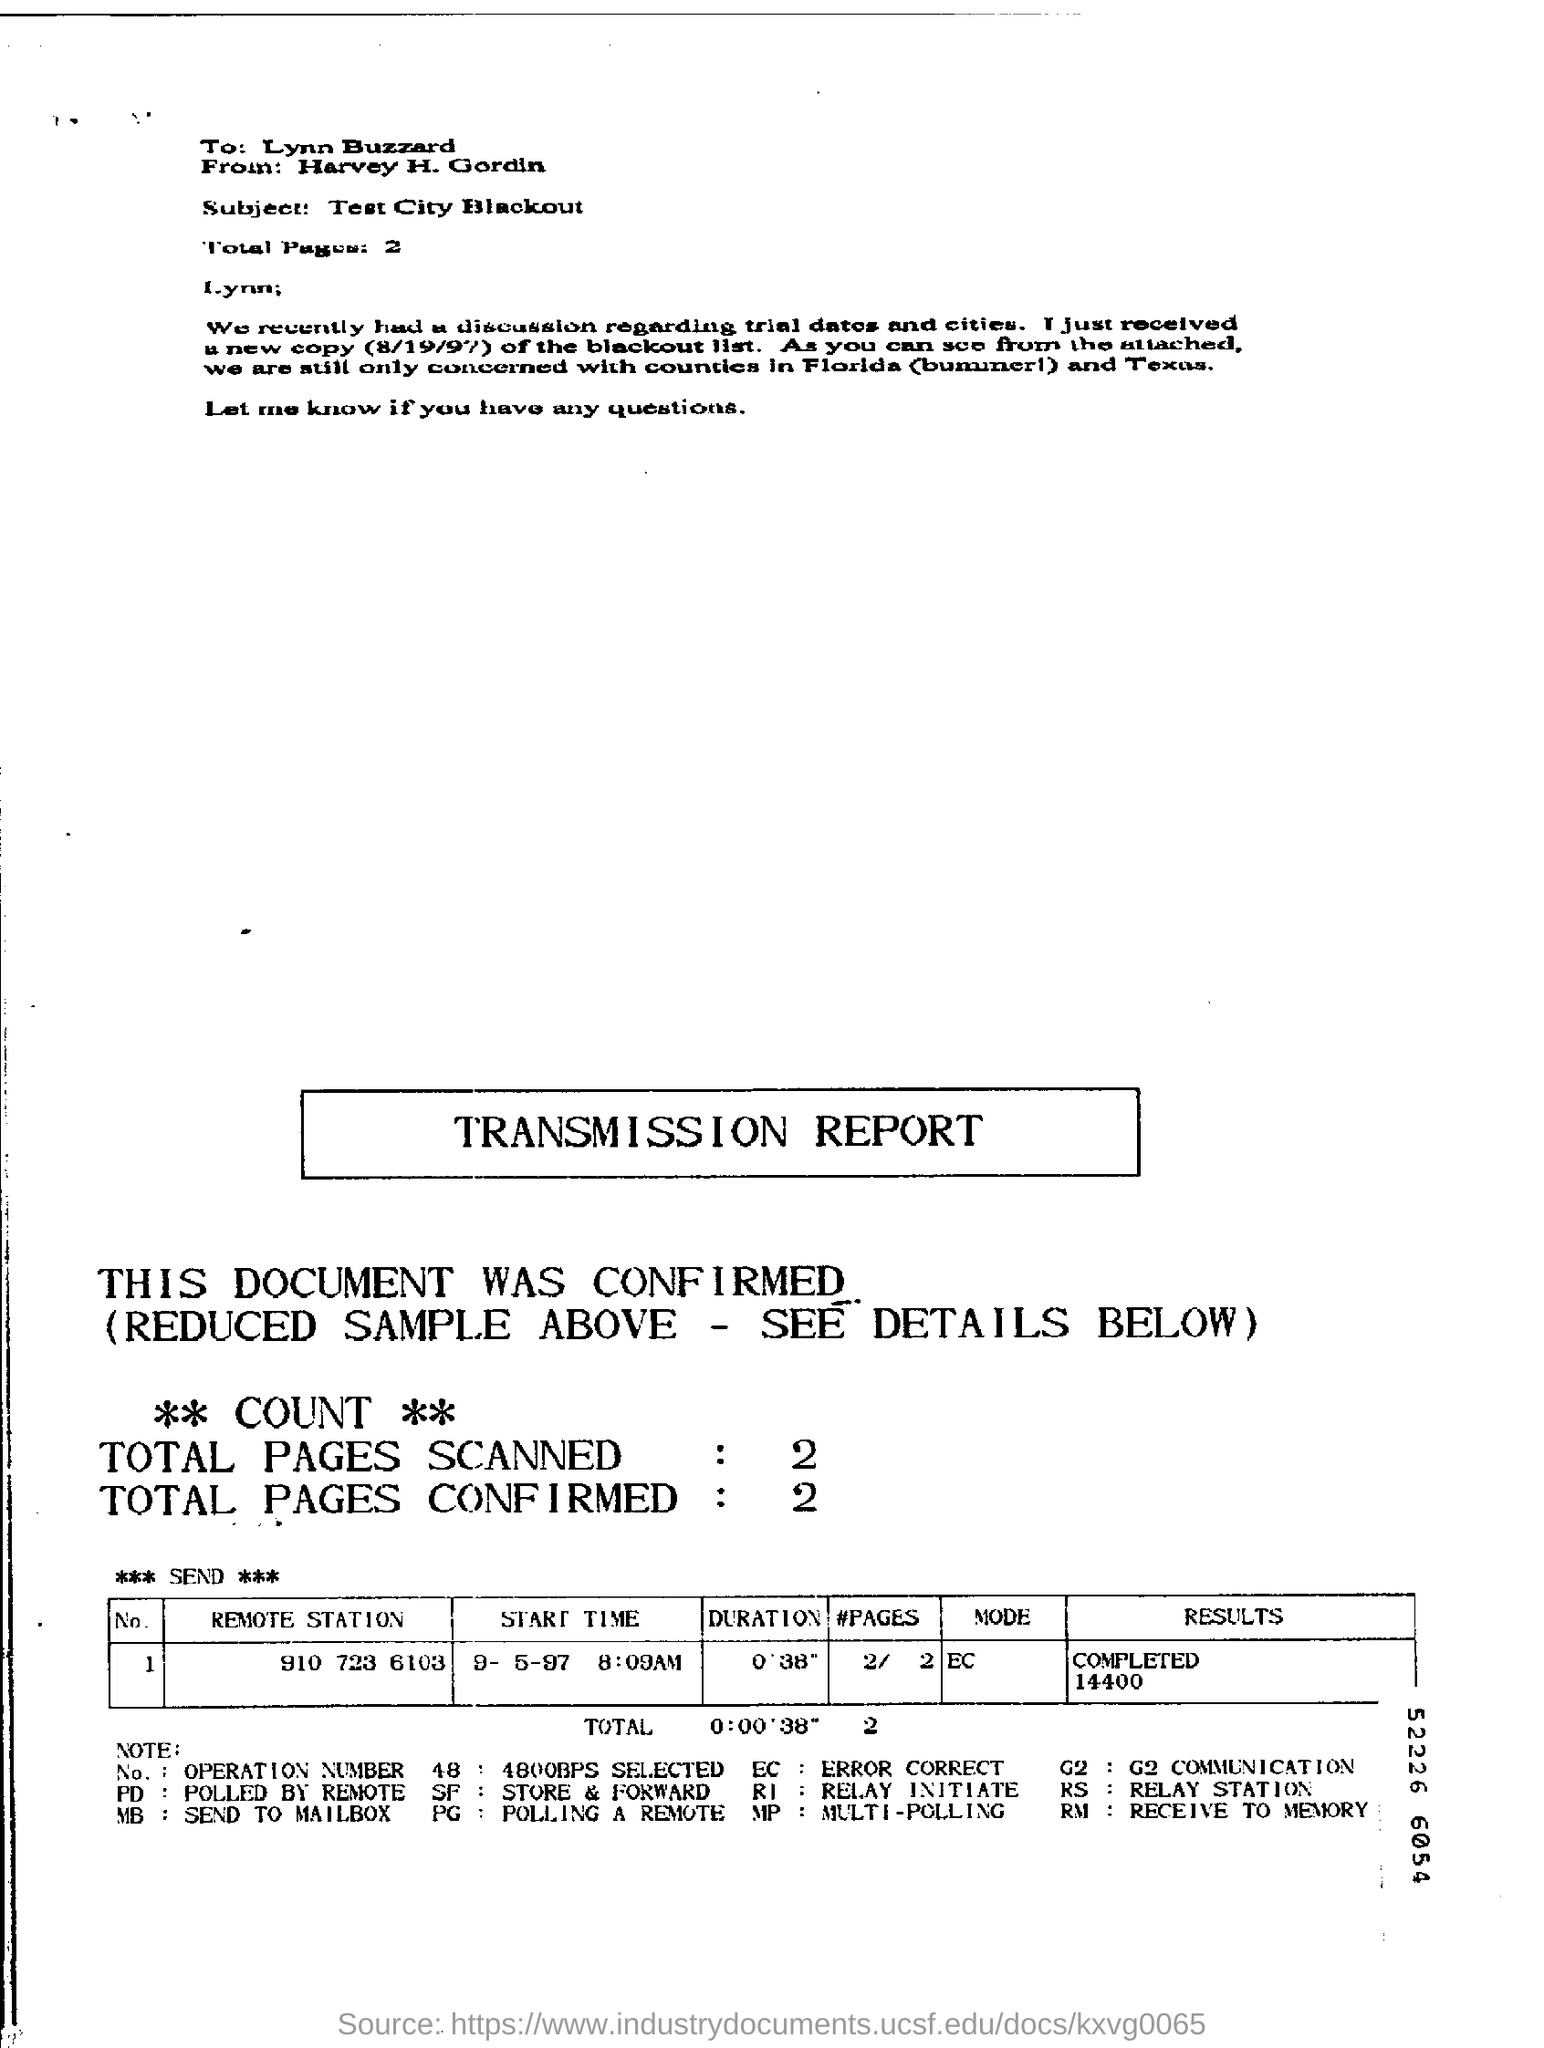Who sent the letter ?
Offer a very short reply. Harvey H. Gordin. What is the subject of the letter ?
Offer a terse response. Test City Blackout. To whom is the letter addressed ?
Ensure brevity in your answer.  Lynn Buzzard. 